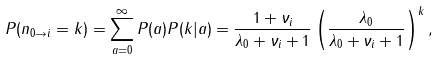<formula> <loc_0><loc_0><loc_500><loc_500>P ( n _ { 0 \rightarrow i } = k ) = \sum _ { a = 0 } ^ { \infty } P ( a ) P ( k | a ) = \frac { 1 + \nu _ { i } } { \lambda _ { 0 } + \nu _ { i } + 1 } \left ( \frac { \lambda _ { 0 } } { \lambda _ { 0 } + \nu _ { i } + 1 } \right ) ^ { k } ,</formula> 